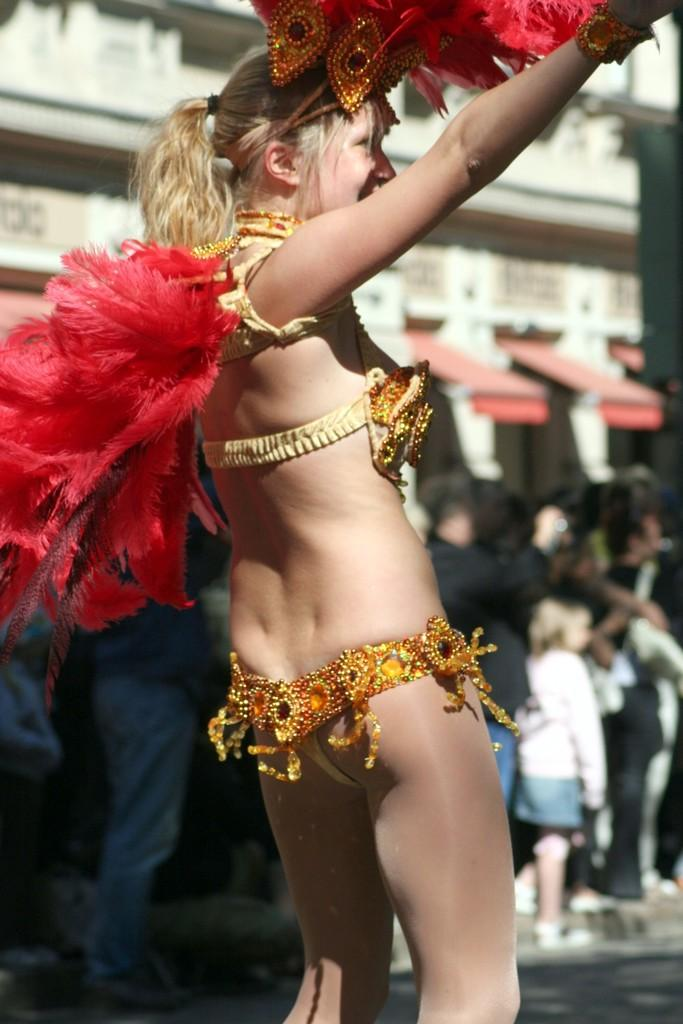What is the woman in the image doing? The woman is dancing in the image. What is the woman holding while dancing? The woman is holding feathers. Can you describe the setting of the image? There are many people in the background of the image, and there is a road at the bottom of the image. What type of rod can be seen in the aftermath of the woman's dance in the image? There is no rod or any aftermath of the woman's dance present in the image. 